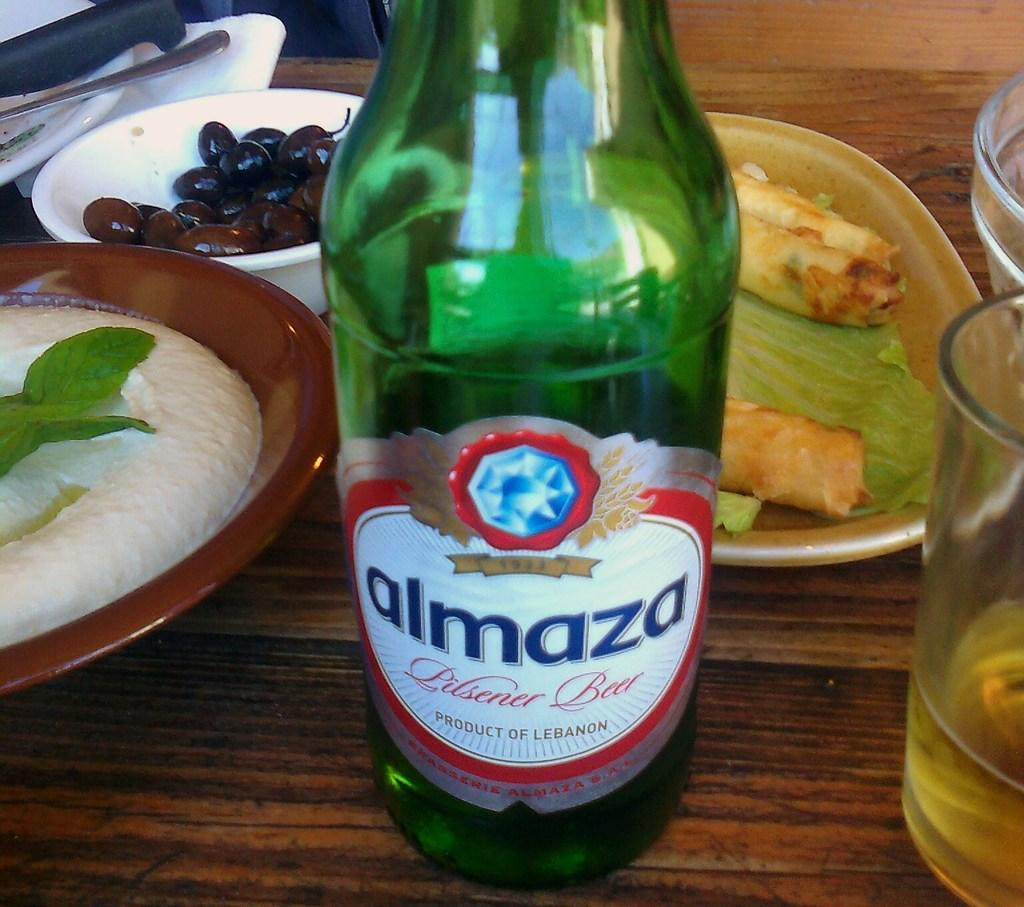What is the name of the glass bottle in the image? The glass bottle in the image is named Almaza. What type of food can be seen in the image? There are bowls and plates of food in the image. What is in the glass that is visible in the image? There is a glass filled with a drink in the image. How many girls are sitting on the clam in the image? There are no girls or clams present in the image. 